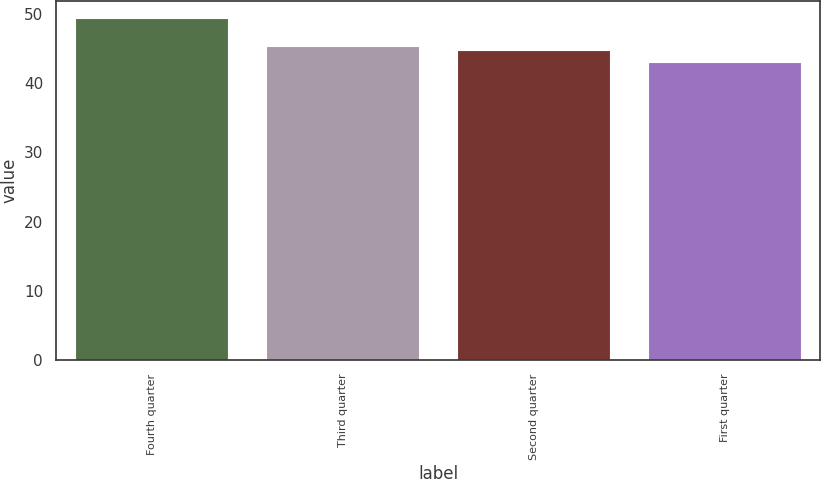<chart> <loc_0><loc_0><loc_500><loc_500><bar_chart><fcel>Fourth quarter<fcel>Third quarter<fcel>Second quarter<fcel>First quarter<nl><fcel>49.35<fcel>45.4<fcel>44.76<fcel>42.99<nl></chart> 